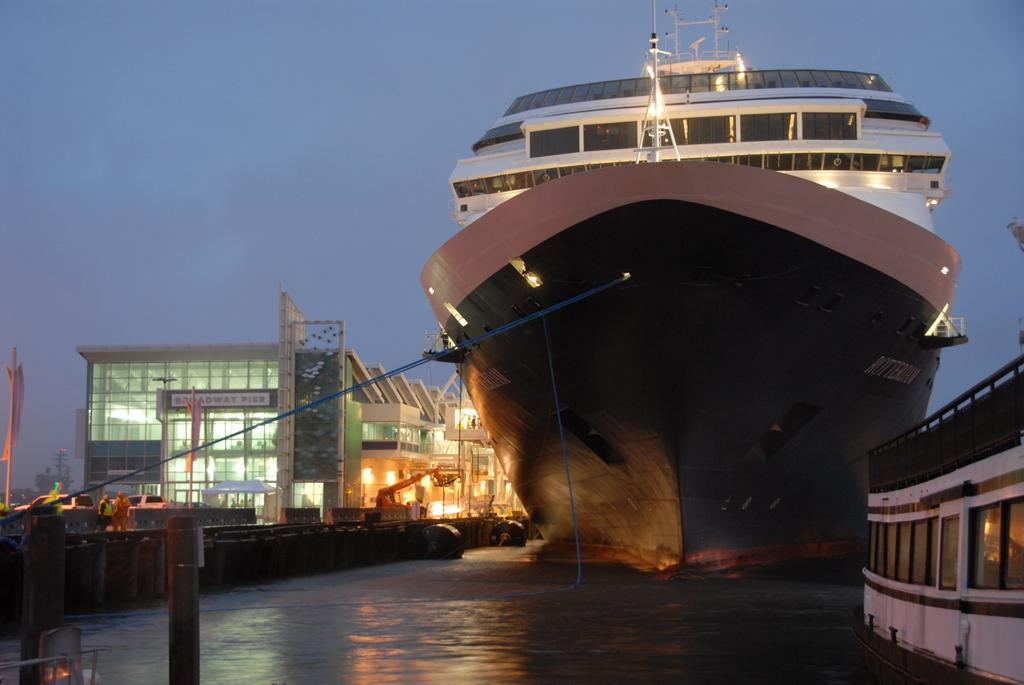<image>
Offer a succinct explanation of the picture presented. a hige ship sits beside a glass front building with a Broadway sign 